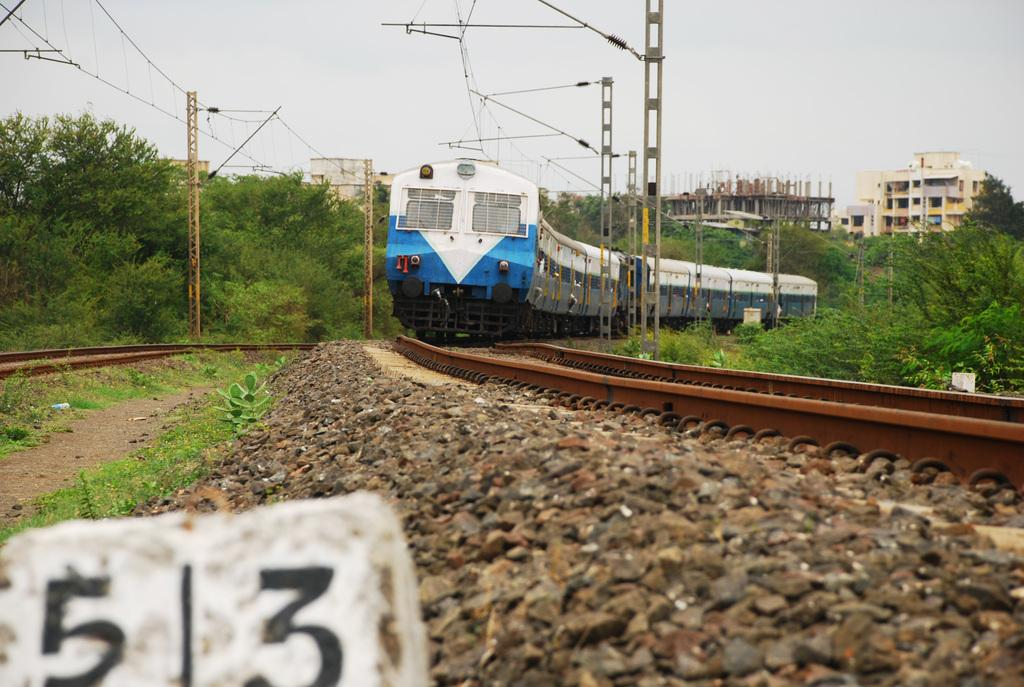<image>
Give a short and clear explanation of the subsequent image. A blue and white train is coming around the corner, towards a rock that has the number 53 painted on it. 